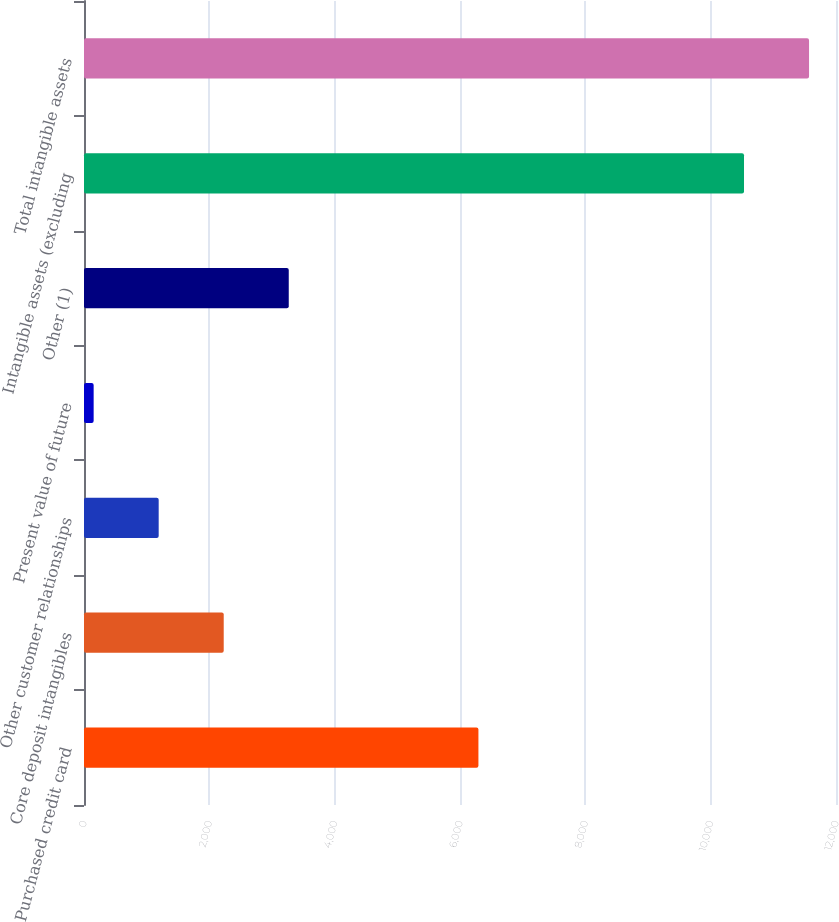Convert chart. <chart><loc_0><loc_0><loc_500><loc_500><bar_chart><fcel>Purchased credit card<fcel>Core deposit intangibles<fcel>Other customer relationships<fcel>Present value of future<fcel>Other (1)<fcel>Intangible assets (excluding<fcel>Total intangible assets<nl><fcel>6294<fcel>2229.6<fcel>1191.8<fcel>154<fcel>3267.4<fcel>10532<fcel>11569.8<nl></chart> 